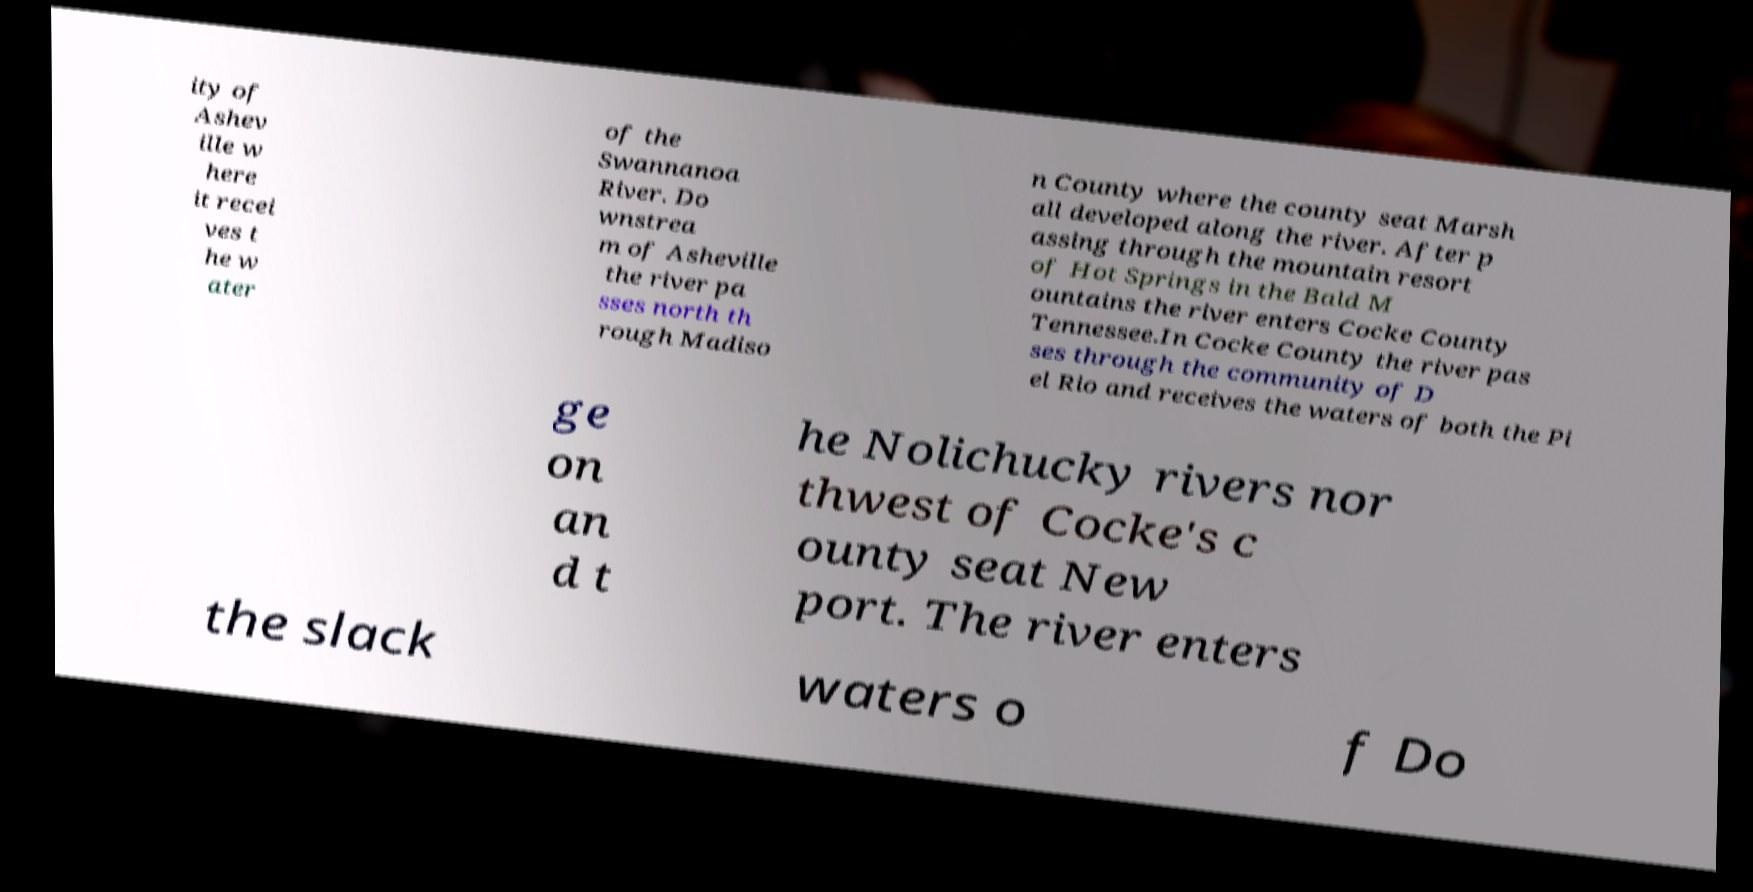There's text embedded in this image that I need extracted. Can you transcribe it verbatim? ity of Ashev ille w here it recei ves t he w ater of the Swannanoa River. Do wnstrea m of Asheville the river pa sses north th rough Madiso n County where the county seat Marsh all developed along the river. After p assing through the mountain resort of Hot Springs in the Bald M ountains the river enters Cocke County Tennessee.In Cocke County the river pas ses through the community of D el Rio and receives the waters of both the Pi ge on an d t he Nolichucky rivers nor thwest of Cocke's c ounty seat New port. The river enters the slack waters o f Do 